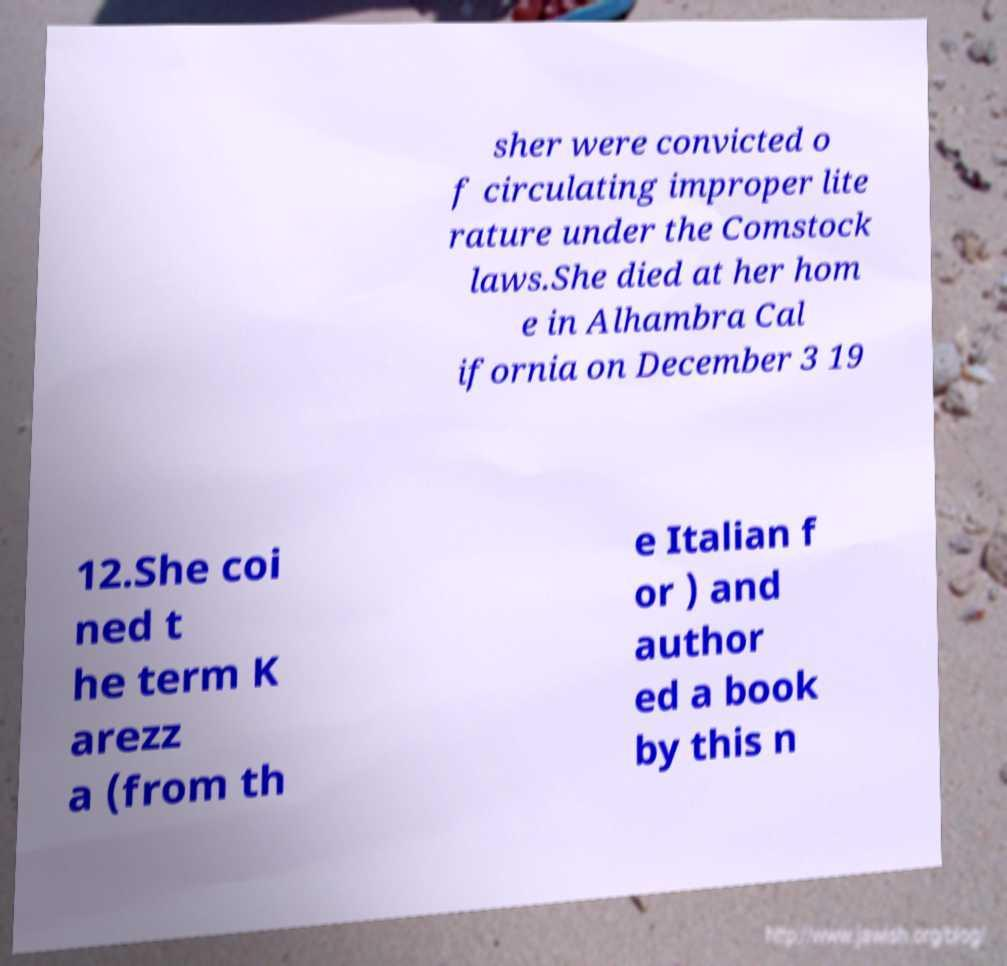Could you extract and type out the text from this image? sher were convicted o f circulating improper lite rature under the Comstock laws.She died at her hom e in Alhambra Cal ifornia on December 3 19 12.She coi ned t he term K arezz a (from th e Italian f or ) and author ed a book by this n 